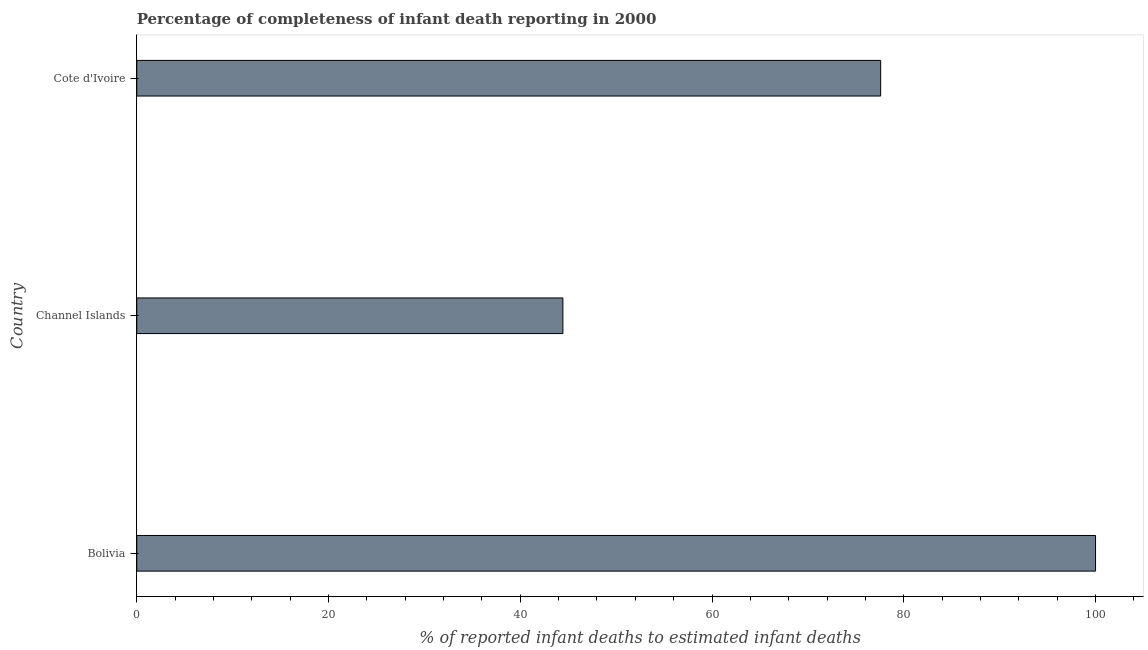What is the title of the graph?
Offer a terse response. Percentage of completeness of infant death reporting in 2000. What is the label or title of the X-axis?
Offer a very short reply. % of reported infant deaths to estimated infant deaths. What is the label or title of the Y-axis?
Keep it short and to the point. Country. Across all countries, what is the minimum completeness of infant death reporting?
Provide a short and direct response. 44.44. In which country was the completeness of infant death reporting maximum?
Your response must be concise. Bolivia. In which country was the completeness of infant death reporting minimum?
Make the answer very short. Channel Islands. What is the sum of the completeness of infant death reporting?
Provide a succinct answer. 222.03. What is the difference between the completeness of infant death reporting in Channel Islands and Cote d'Ivoire?
Keep it short and to the point. -33.14. What is the average completeness of infant death reporting per country?
Provide a succinct answer. 74.01. What is the median completeness of infant death reporting?
Keep it short and to the point. 77.59. In how many countries, is the completeness of infant death reporting greater than 64 %?
Your answer should be compact. 2. What is the ratio of the completeness of infant death reporting in Bolivia to that in Cote d'Ivoire?
Make the answer very short. 1.29. Is the completeness of infant death reporting in Bolivia less than that in Channel Islands?
Provide a succinct answer. No. Is the difference between the completeness of infant death reporting in Bolivia and Channel Islands greater than the difference between any two countries?
Provide a short and direct response. Yes. What is the difference between the highest and the second highest completeness of infant death reporting?
Give a very brief answer. 22.41. Is the sum of the completeness of infant death reporting in Channel Islands and Cote d'Ivoire greater than the maximum completeness of infant death reporting across all countries?
Offer a terse response. Yes. What is the difference between the highest and the lowest completeness of infant death reporting?
Your response must be concise. 55.56. In how many countries, is the completeness of infant death reporting greater than the average completeness of infant death reporting taken over all countries?
Provide a succinct answer. 2. How many countries are there in the graph?
Offer a very short reply. 3. What is the difference between two consecutive major ticks on the X-axis?
Your answer should be compact. 20. Are the values on the major ticks of X-axis written in scientific E-notation?
Keep it short and to the point. No. What is the % of reported infant deaths to estimated infant deaths in Bolivia?
Offer a very short reply. 100. What is the % of reported infant deaths to estimated infant deaths of Channel Islands?
Offer a very short reply. 44.44. What is the % of reported infant deaths to estimated infant deaths in Cote d'Ivoire?
Ensure brevity in your answer.  77.59. What is the difference between the % of reported infant deaths to estimated infant deaths in Bolivia and Channel Islands?
Ensure brevity in your answer.  55.56. What is the difference between the % of reported infant deaths to estimated infant deaths in Bolivia and Cote d'Ivoire?
Provide a short and direct response. 22.41. What is the difference between the % of reported infant deaths to estimated infant deaths in Channel Islands and Cote d'Ivoire?
Ensure brevity in your answer.  -33.14. What is the ratio of the % of reported infant deaths to estimated infant deaths in Bolivia to that in Channel Islands?
Offer a very short reply. 2.25. What is the ratio of the % of reported infant deaths to estimated infant deaths in Bolivia to that in Cote d'Ivoire?
Provide a short and direct response. 1.29. What is the ratio of the % of reported infant deaths to estimated infant deaths in Channel Islands to that in Cote d'Ivoire?
Your response must be concise. 0.57. 